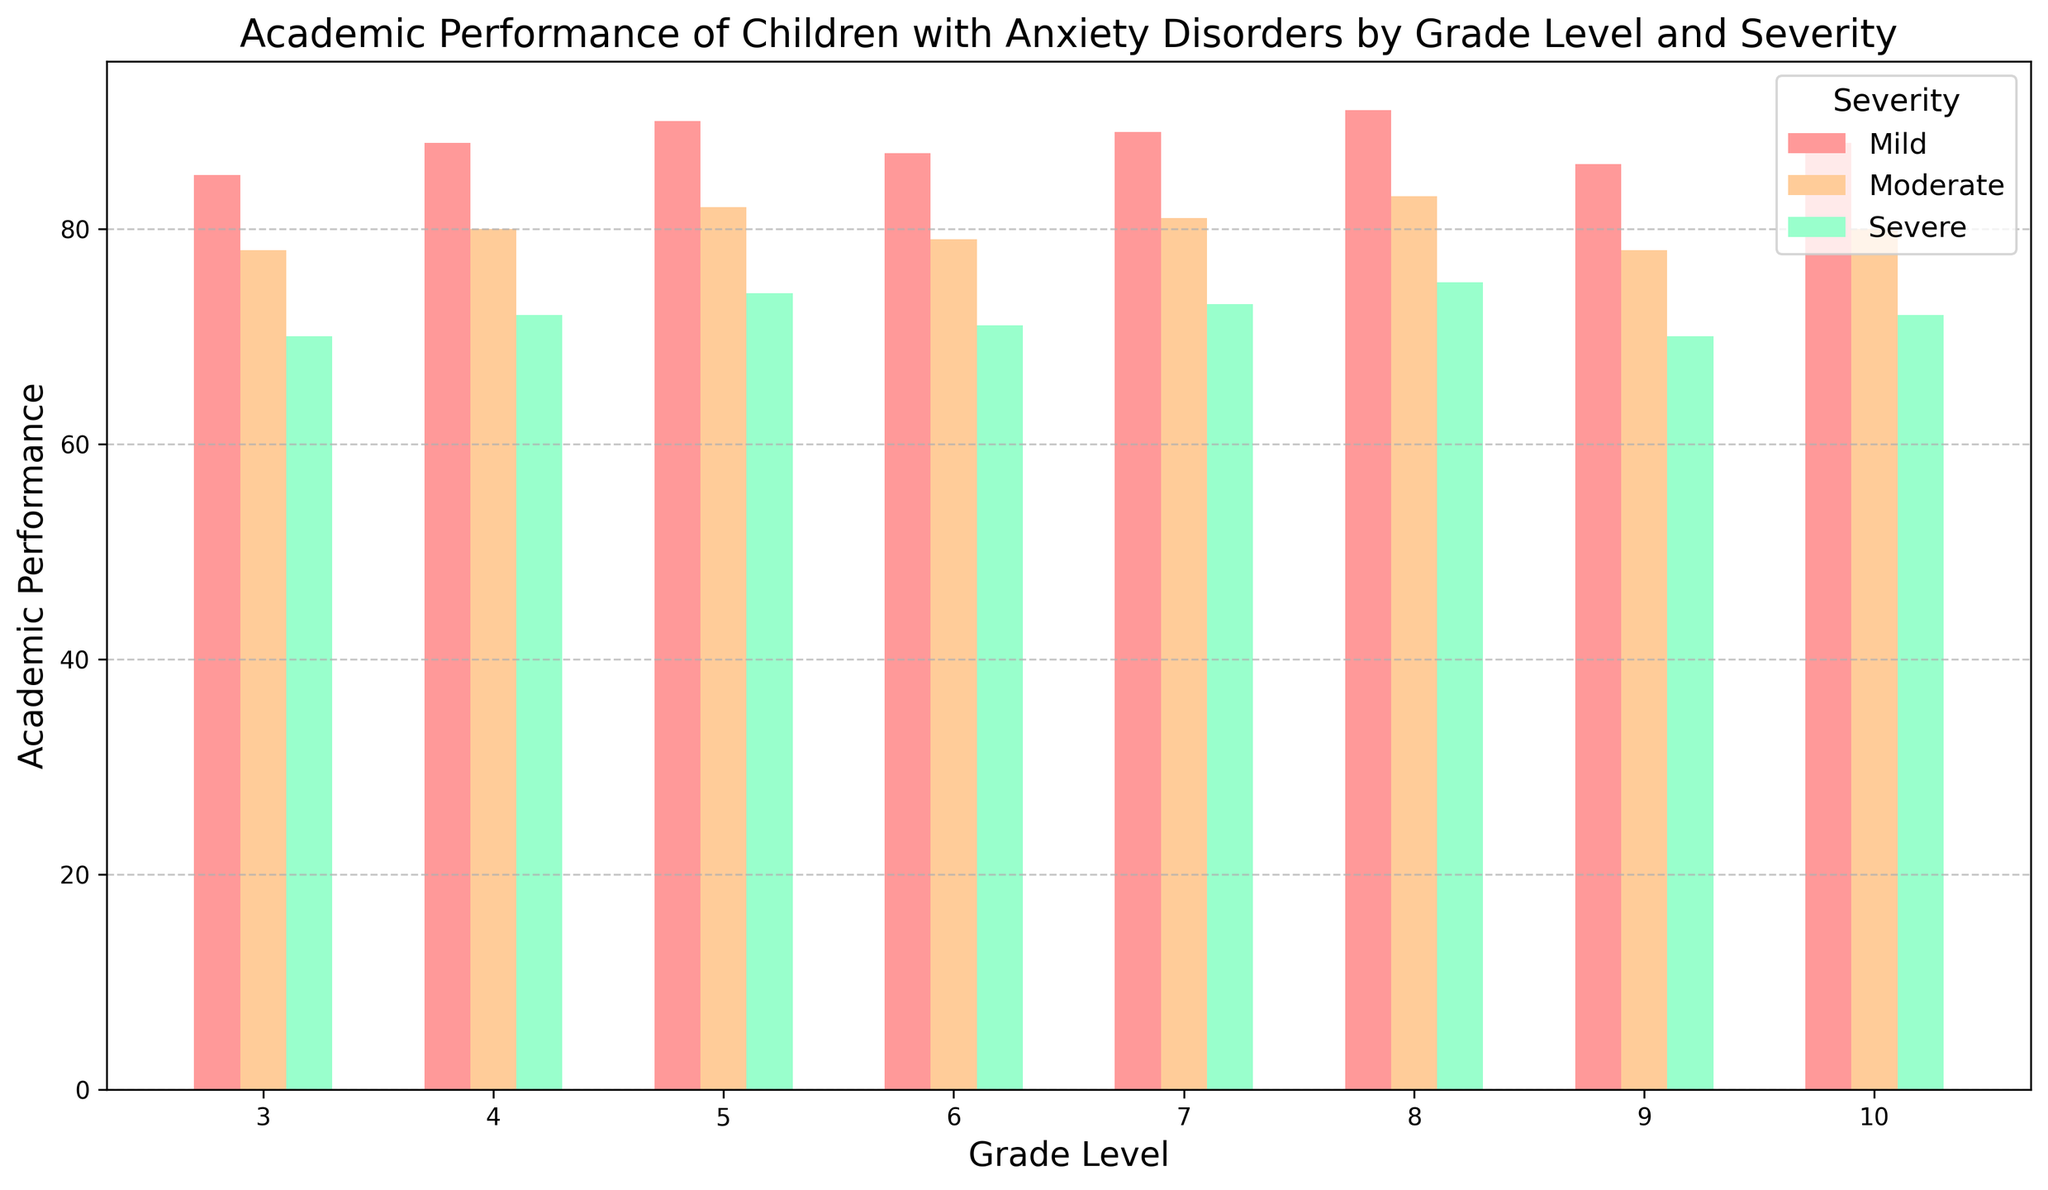What is the academic performance of 7th graders with moderate anxiety? Look at the bar representing 7th grade under the "Moderate" severity label. The height of the bar corresponds to the academic performance score.
Answer: 81 Which grade level shows the highest academic performance across all severity levels? Compare the tallest bars (indicating the highest academic performance) in each severity category across all grades. Notice that for mild anxiety, 8th grade has the tallest bar representing an academic performance of 91, which is the highest across all grades.
Answer: 8th grade Is the academic performance of 4th graders with severe anxiety better or worse than 9th graders with moderate anxiety? Look at the bar height for 4th grade under severe anxiety and for 9th grade under moderate anxiety. The bar for 4th grade severe anxiety represents a performance of 72, and the bar for 9th grade moderate anxiety shows a performance of 78.
Answer: Worse What is the average academic performance of children with moderate anxiety across all grades? Extract the academic performance scores for moderate anxiety across all grades: 78, 80, 82, 79, 81, 83, 78, 80. Calculate their average: (78 + 80 + 82 + 79 + 81 + 83 + 78 + 80) / 8 = 80.125.
Answer: 80.125 By how much does the academic performance of 6th graders with mild anxiety exceed that of 6th graders with severe anxiety? Subtract the performance score of 6th grade students with severe anxiety (71) from the performance of 6th grade students with mild anxiety (87): 87 - 71.
Answer: 16 Does the academic performance of children with severe anxiety show any noticeable trends across the grade levels? Observe the bars for severe anxiety across all grades. The pattern shows a gradual increase from 3rd grade (70) to 8th grade (75) and then a drop again for 9th grade (70) and 10th grade (72).
Answer: Increase until 8th grade, then decrease Which grade level shows the least impact of anxiety severity on academic performance? Compare the differences in bar heights across severity levels for each grade. Notice that 5th grade shows relatively smaller differences between mild, moderate, and severe scores (90, 82, 74), indicating a lesser impact.
Answer: 5th grade What is the total academic performance score for all grades with mild anxiety? Sum the academic performance scores for mild anxiety across all grades: 85, 88, 90, 87, 89, 91, 86, 88. Calculation: 85 + 88 + 90 + 87 + 89 + 91 + 86 + 88 = 704.
Answer: 704 